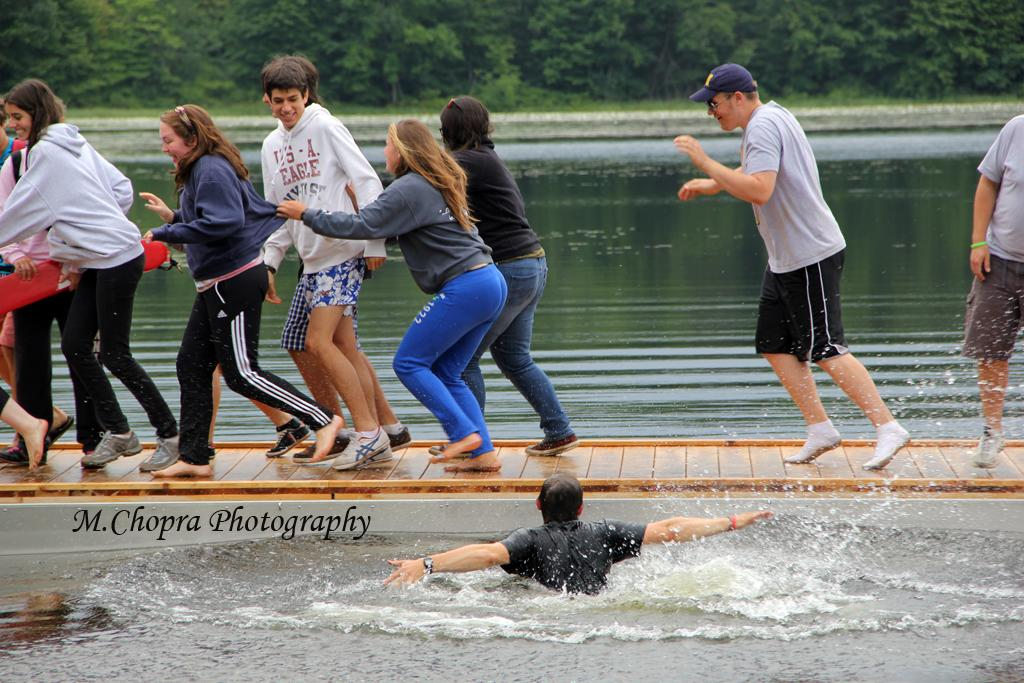What are the people in the image doing? The people in the image are walking on the surface. Can you describe the person in the water? There is a person in the water in the image. What can be seen written or displayed in the image? There is text visible in the image. What type of vegetation is visible in the background of the image? There are trees in the background of the image. What other natural elements can be seen in the background of the image? There is grass in the background of the image. What type of bead is being used for comfort by the person in the water? There is no bead present in the image, and the person in the water is not using any beads for comfort. 